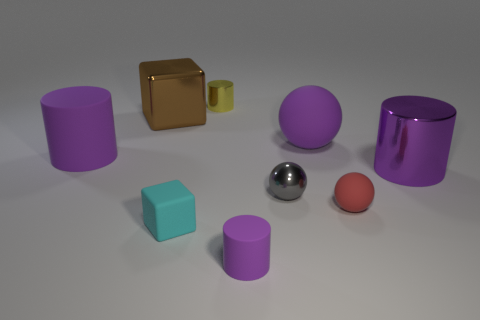What number of other objects are there of the same color as the big ball?
Provide a succinct answer. 3. What shape is the small thing behind the purple rubber thing that is to the left of the big metal thing that is on the left side of the small yellow metallic object?
Provide a succinct answer. Cylinder. The brown thing has what size?
Ensure brevity in your answer.  Large. Is there a tiny red object that has the same material as the tiny red ball?
Your answer should be compact. No. What size is the yellow thing that is the same shape as the big purple metallic object?
Your answer should be very brief. Small. Is the number of gray spheres to the left of the tiny gray ball the same as the number of large yellow metallic things?
Your answer should be very brief. Yes. There is a large rubber object that is to the left of the tiny purple cylinder; does it have the same shape as the tiny yellow metal object?
Ensure brevity in your answer.  Yes. The tiny cyan object is what shape?
Give a very brief answer. Cube. There is a small cylinder behind the tiny matte object left of the matte cylinder that is in front of the tiny red rubber object; what is its material?
Your response must be concise. Metal. There is another big cylinder that is the same color as the big matte cylinder; what material is it?
Your answer should be compact. Metal. 